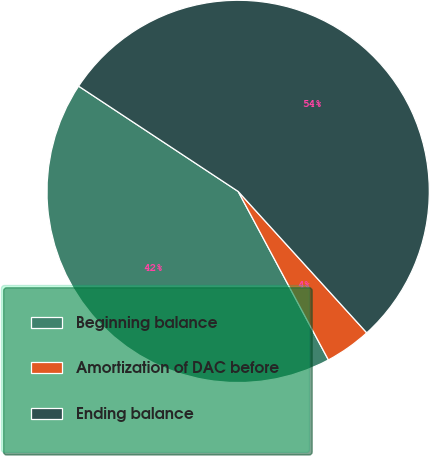Convert chart to OTSL. <chart><loc_0><loc_0><loc_500><loc_500><pie_chart><fcel>Beginning balance<fcel>Amortization of DAC before<fcel>Ending balance<nl><fcel>42.11%<fcel>3.92%<fcel>53.97%<nl></chart> 